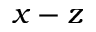<formula> <loc_0><loc_0><loc_500><loc_500>x - z</formula> 